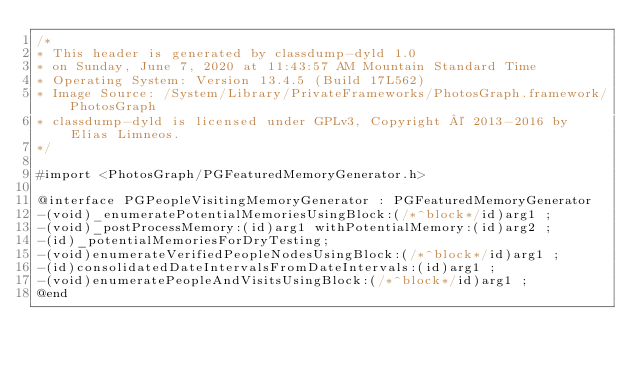Convert code to text. <code><loc_0><loc_0><loc_500><loc_500><_C_>/*
* This header is generated by classdump-dyld 1.0
* on Sunday, June 7, 2020 at 11:43:57 AM Mountain Standard Time
* Operating System: Version 13.4.5 (Build 17L562)
* Image Source: /System/Library/PrivateFrameworks/PhotosGraph.framework/PhotosGraph
* classdump-dyld is licensed under GPLv3, Copyright © 2013-2016 by Elias Limneos.
*/

#import <PhotosGraph/PGFeaturedMemoryGenerator.h>

@interface PGPeopleVisitingMemoryGenerator : PGFeaturedMemoryGenerator
-(void)_enumeratePotentialMemoriesUsingBlock:(/*^block*/id)arg1 ;
-(void)_postProcessMemory:(id)arg1 withPotentialMemory:(id)arg2 ;
-(id)_potentialMemoriesForDryTesting;
-(void)enumerateVerifiedPeopleNodesUsingBlock:(/*^block*/id)arg1 ;
-(id)consolidatedDateIntervalsFromDateIntervals:(id)arg1 ;
-(void)enumeratePeopleAndVisitsUsingBlock:(/*^block*/id)arg1 ;
@end

</code> 